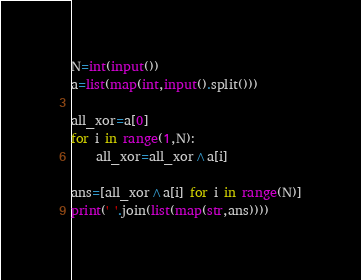Convert code to text. <code><loc_0><loc_0><loc_500><loc_500><_Python_>N=int(input())
a=list(map(int,input().split()))

all_xor=a[0]
for i in range(1,N):
    all_xor=all_xor^a[i]
    
ans=[all_xor^a[i] for i in range(N)]
print(' '.join(list(map(str,ans))))</code> 